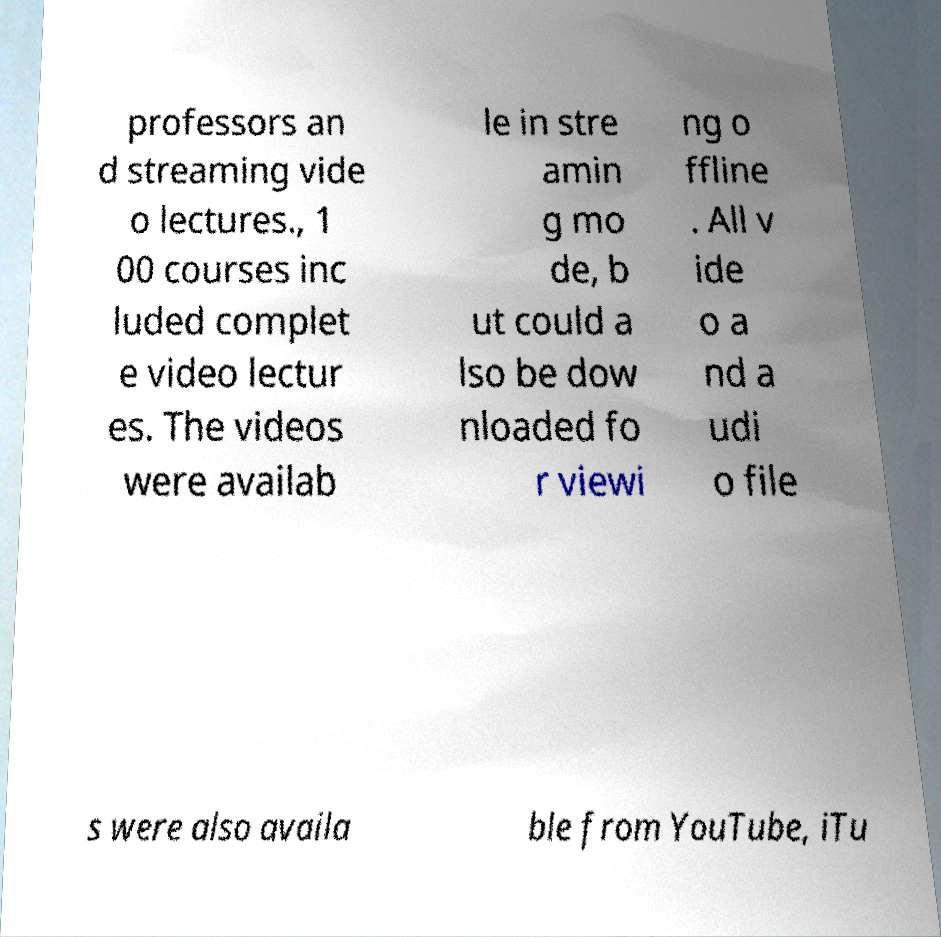Could you extract and type out the text from this image? professors an d streaming vide o lectures., 1 00 courses inc luded complet e video lectur es. The videos were availab le in stre amin g mo de, b ut could a lso be dow nloaded fo r viewi ng o ffline . All v ide o a nd a udi o file s were also availa ble from YouTube, iTu 